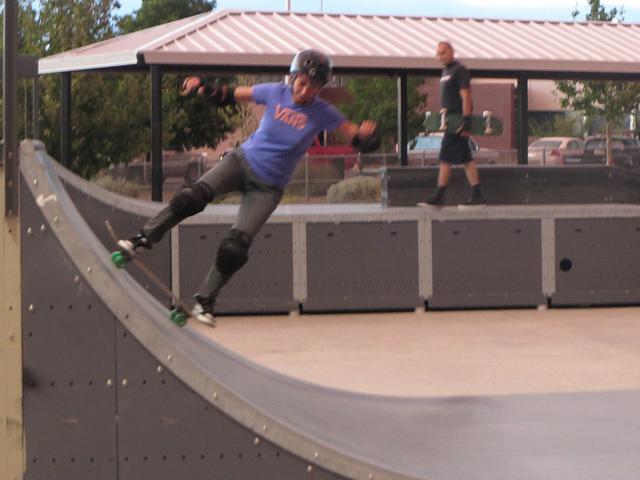What color are the man's socks?
Quick response, please. Black. How many people are in this picture?
Write a very short answer. 2. Is this a man or a woman in the blue shirt?
Answer briefly. Woman. 